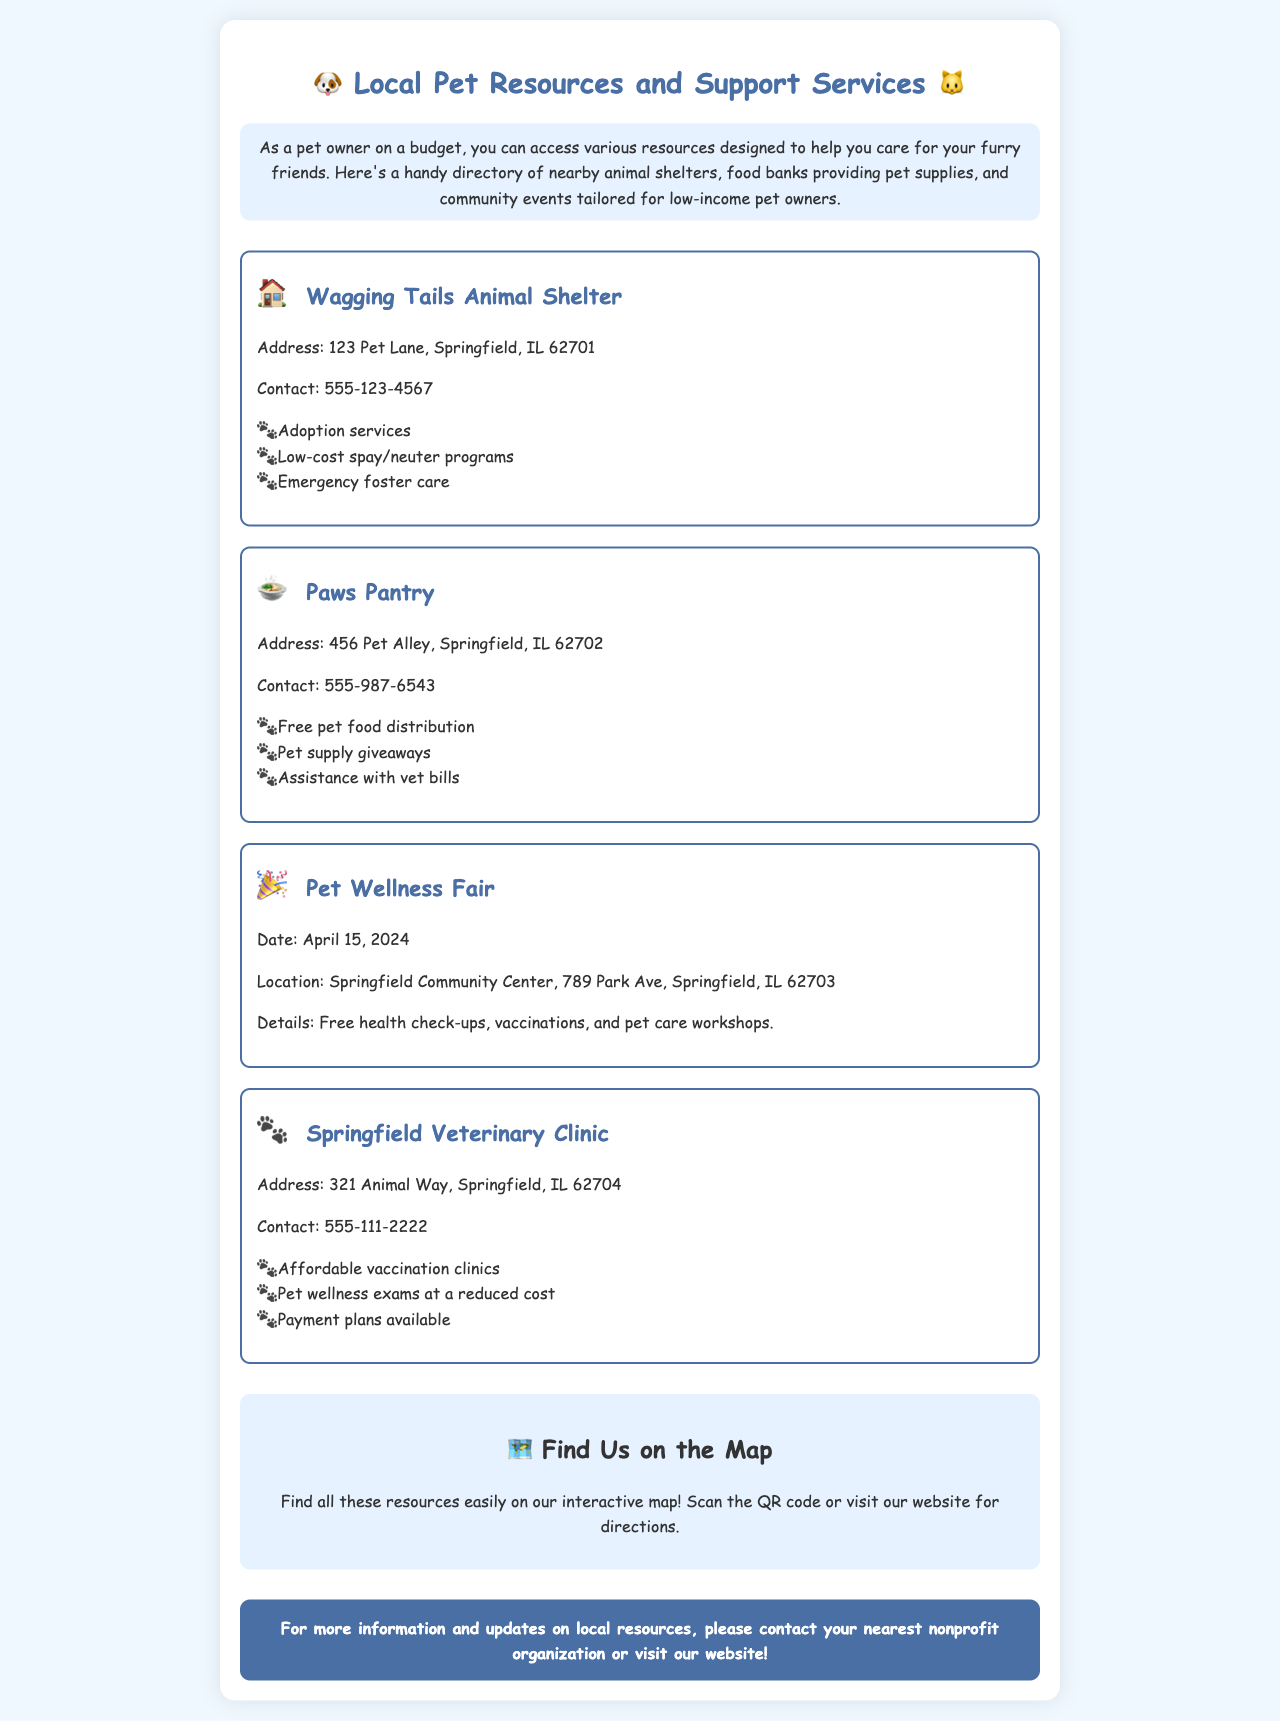What is the address of Wagging Tails Animal Shelter? The address for Wagging Tails Animal Shelter is specifically noted in the document.
Answer: 123 Pet Lane, Springfield, IL 62701 What services does Paws Pantry provide? Paws Pantry offers a range of specific services that are listed in the document.
Answer: Free pet food distribution, pet supply giveaways, assistance with vet bills When is the Pet Wellness Fair? The date for the Pet Wellness Fair is explicitly provided in the document.
Answer: April 15, 2024 What is offered at the Springfield Veterinary Clinic? The document lists multiple services available at the Springfield Veterinary Clinic.
Answer: Affordable vaccination clinics, pet wellness exams at a reduced cost, payment plans available Where is the Pet Wellness Fair located? The location for the Pet Wellness Fair is mentioned in the document.
Answer: Springfield Community Center, 789 Park Ave, Springfield, IL 62703 What type of resource is Paws Pantry? Paws Pantry is categorized in the document as a specific type of resource for pet owners.
Answer: Food bank What does the interactive map provide? The document describes the purpose of the interactive map.
Answer: Directions to resources How can I find more local resources? The document mentions how to get more information about local resources.
Answer: Contact your nearest nonprofit organization or visit our website 